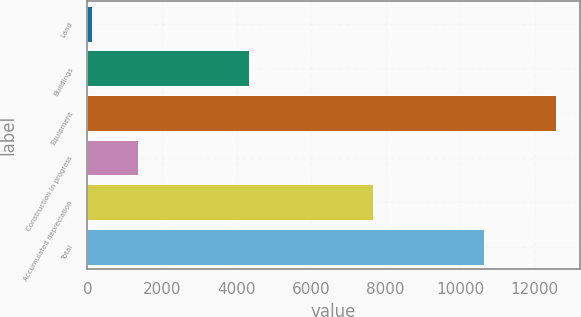Convert chart. <chart><loc_0><loc_0><loc_500><loc_500><bar_chart><fcel>Land<fcel>Buildings<fcel>Equipment<fcel>Construction in progress<fcel>Accumulated depreciation<fcel>Total<nl><fcel>112<fcel>4324<fcel>12571<fcel>1357.9<fcel>7652<fcel>10625<nl></chart> 